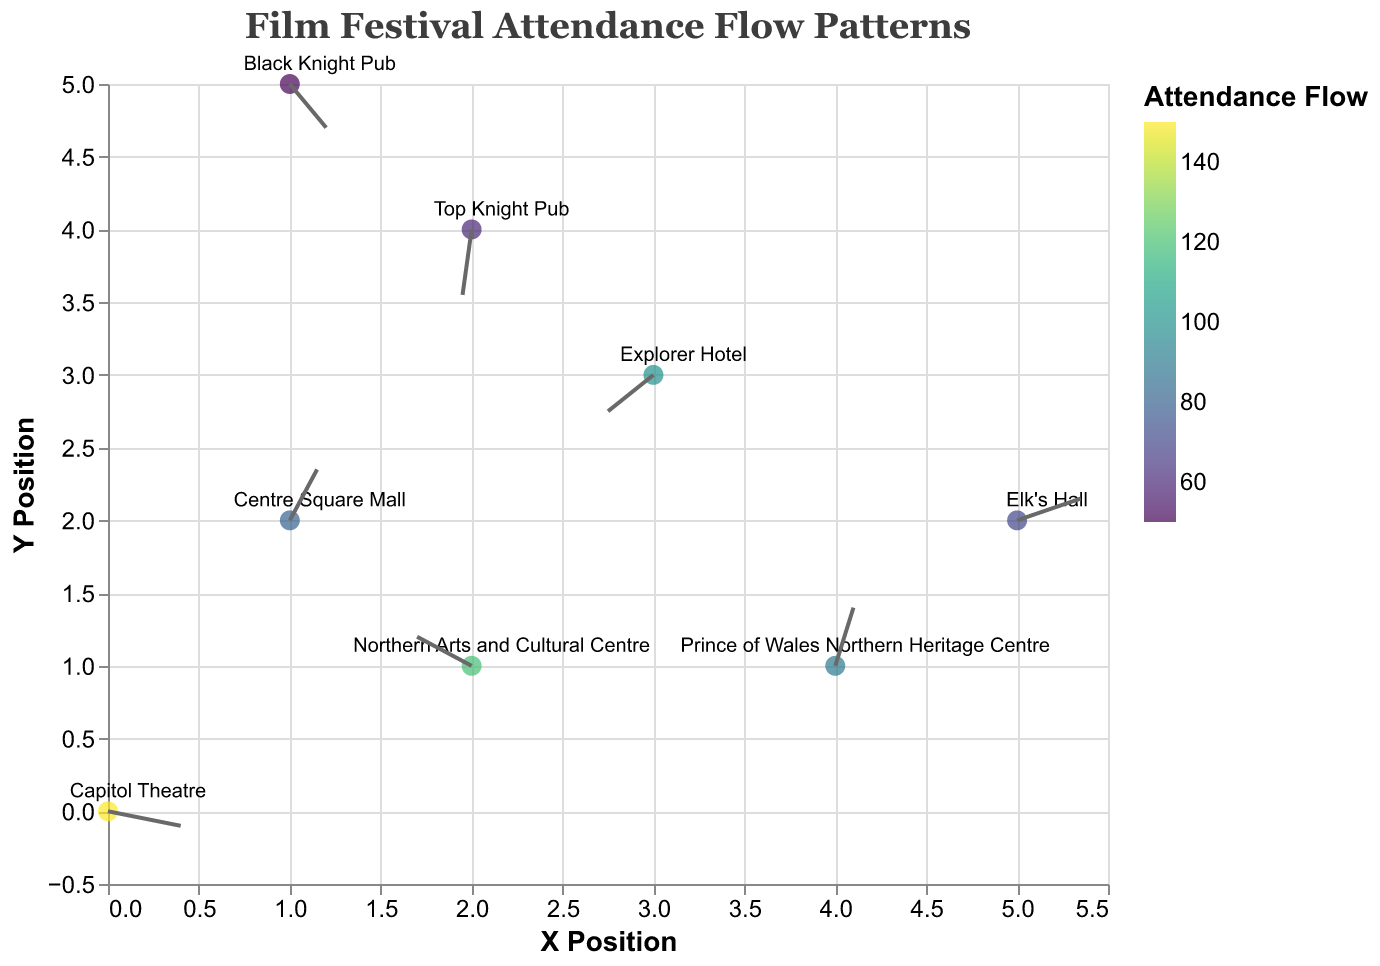How many venues are mapped in the figure? By observing the figure, we see each venue marked with a point; counting these points shows the total number of venues.
Answer: 8 Which venue has the highest attendance flow? The figure uses color to indicate attendance flow, with a specific legend showing higher attendance corresponds to a particular color. The venue with the most intense color representing the highest value is identified.
Answer: Capitol Theatre What is the average attendance flow across all venues? We sum the attendance values of all venues (150 + 120 + 80 + 100 + 90 + 60 + 70 + 50 = 720) and divide it by the number of venues (720 / 8).
Answer: 90 Which direction is the attendance flow for the Top Knight Pub? By locating the Top Knight Pub in the figure and examining the direction of the arrow originating from it, we can determine its flow direction.
Answer: Downwards left Compare the attendance flow between Capitol Theatre and Black Knight Pub. Which is higher and by how much? Identify and note the attendance flow for both venues (Capitol Theatre: 150, Black Knight Pub: 50), then subtract the smaller value from the larger value to find the difference.
Answer: Capitol Theatre by 100 Among the given venues, which has the lowest attendance flow? By examining the color legend and identifying the venue with the lightest color, we can determine the venue with the lowest attendance flow.
Answer: Black Knight Pub What is the direction of the flow pattern for the Northern Arts and Cultural Centre? By locating the Northern Arts and Cultural Centre on the figure and observing the arrow originating from it, we can determine the direction of its attendance flow.
Answer: Upwards left How many venues have an attendance flow greater than 90? By examining the attendance flow values on the figure, count how many venues have attendance greater than 90 (Capitol Theatre: 150, Northern Arts and Cultural Centre: 120, Explorer Hotel: 100).
Answer: 3 Which venue is located furthest on the Y-axis? By examining the Y-positions of all venues, the one with the highest Y-coordinate is identified as the furthest on the Y-axis.
Answer: Black Knight Pub 